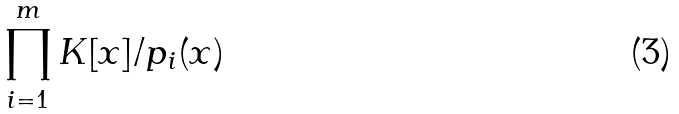Convert formula to latex. <formula><loc_0><loc_0><loc_500><loc_500>\prod _ { i = 1 } ^ { m } K [ x ] / p _ { i } ( x )</formula> 